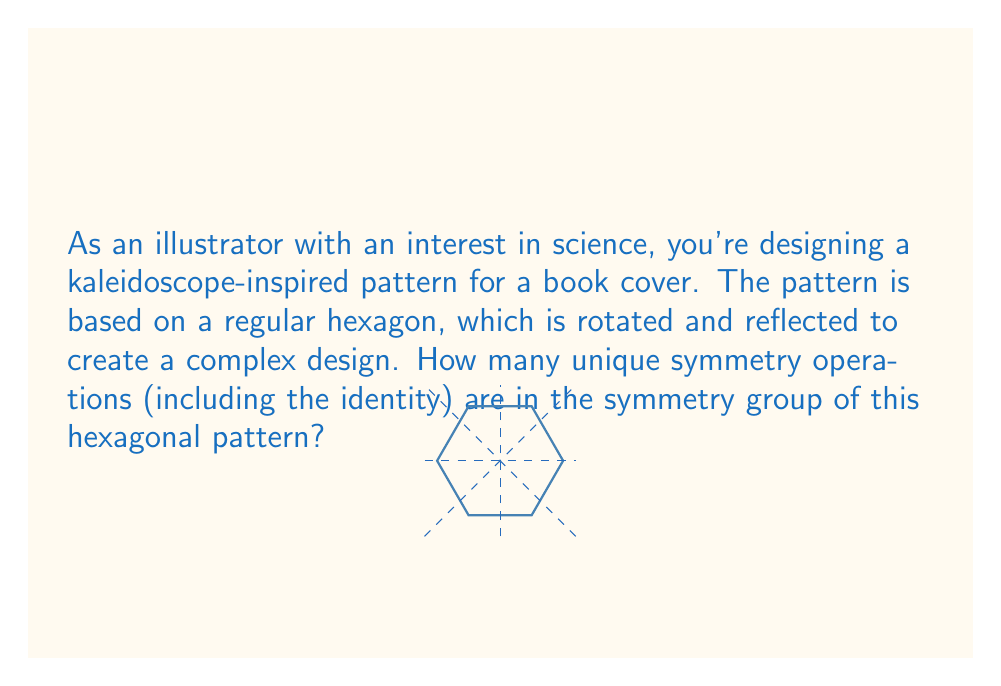Can you answer this question? To determine the number of symmetry operations in the symmetry group of a regular hexagon, we need to consider all possible rotations and reflections that leave the hexagon unchanged. Let's break this down step-by-step:

1. Rotations:
   - The identity operation (rotation by 0°)
   - Rotation by 60°
   - Rotation by 120°
   - Rotation by 180°
   - Rotation by 240°
   - Rotation by 300°
   Total rotations: 6

2. Reflections:
   - Reflection across 3 axes passing through opposite vertices
   - Reflection across 3 axes passing through the midpoints of opposite sides
   Total reflections: 6

3. Symmetry group:
   The symmetry group of a regular hexagon is known as the dihedral group $D_6$. The order of this group is given by the formula:
   
   $$ |D_n| = 2n $$
   
   where $n$ is the number of sides of the regular polygon.

4. Calculation:
   For a hexagon, $n = 6$, so:
   
   $$ |D_6| = 2 \cdot 6 = 12 $$

Therefore, the symmetry group of the hexagonal pattern contains 12 unique symmetry operations, including the identity operation.
Answer: 12 